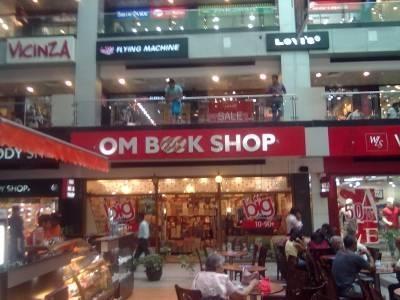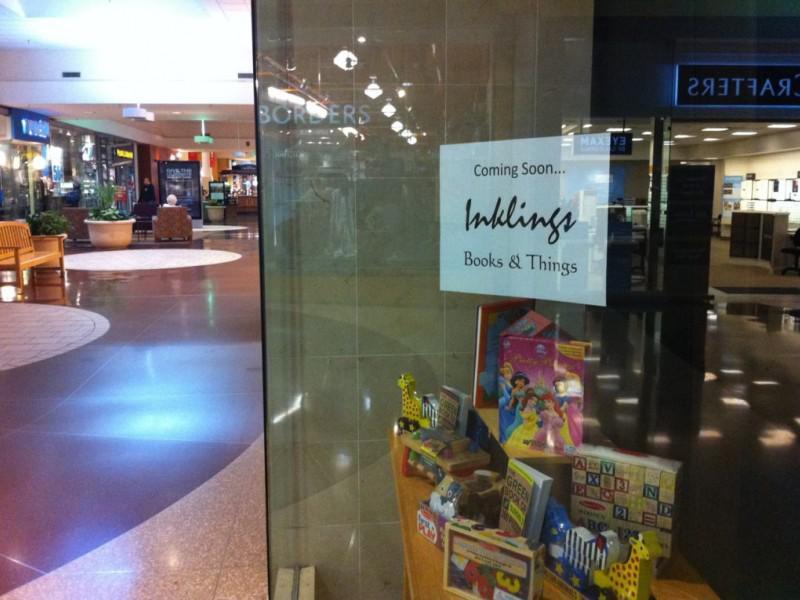The first image is the image on the left, the second image is the image on the right. Examine the images to the left and right. Is the description "Contains a photo of the book store from outside the shop." accurate? Answer yes or no. Yes. 